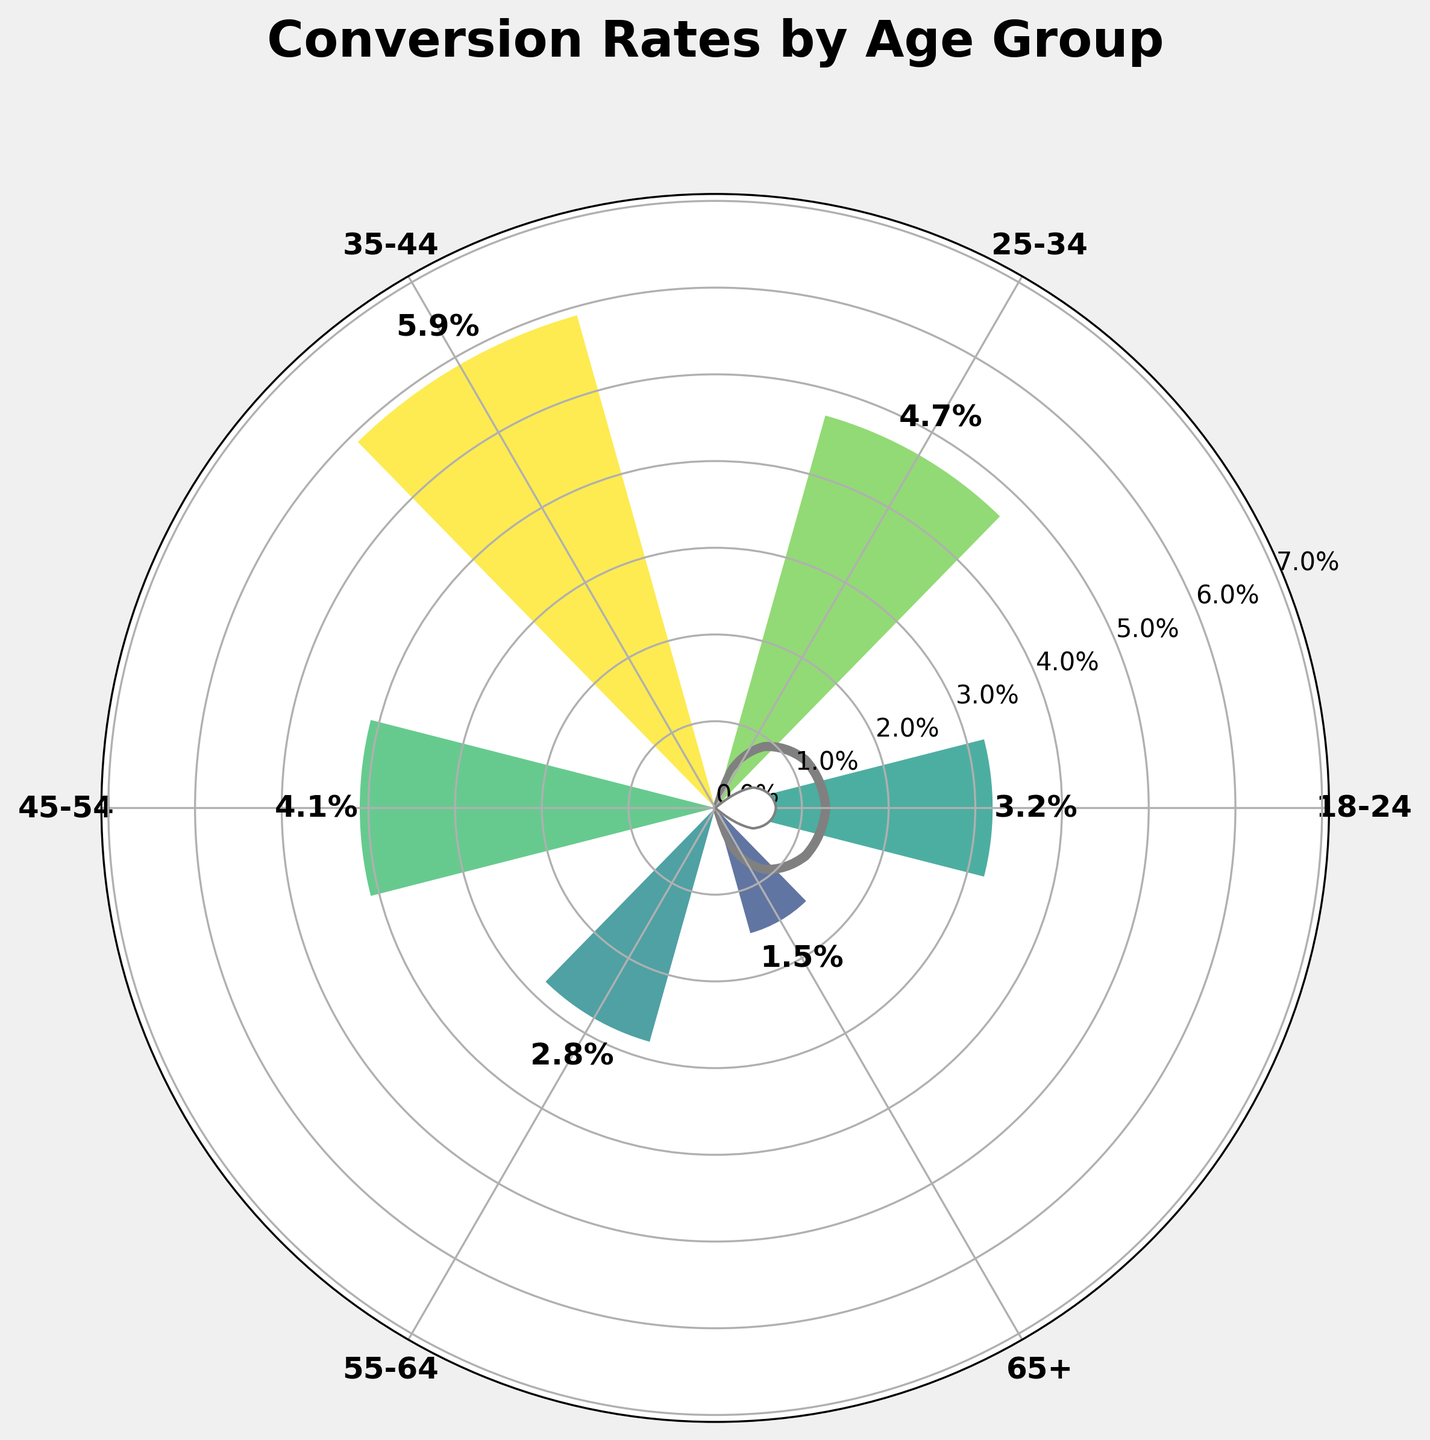What is the conversion rate for the 18-24 age group? To get this information, simply look at the section of the gauge chart labeled "18-24" and check the conversion rate value next to it. The figure shows the conversion rate for each age group on the gauge itself.
Answer: 3.2% What is the highest conversion rate among all age groups? Scan through the conversion rates for all age groups to find the maximum value. The highest conversion rate is clearly labeled on the gauge chart.
Answer: 5.9% How many age groups have a conversion rate below 4%? Look at the conversion rates for each age group on the chart and count how many are below 4%. The age groups with conversion rates below 4% are 18-24, 55-64, and 65+.
Answer: 3 Which age group has the lowest conversion rate? Examine the conversion rates for each age group on the chart to determine the one with the smallest value. The lowest value is annotated next to the age group.
Answer: 65+ What is the difference in conversion rates between the 25-34 and 65+ age groups? Identify the conversion rates for both age groups from the chart—25-34 is 4.7% and 65+ is 1.5%. Subtract the 65+ conversion rate from the 25-34 conversion rate to find the difference.
Answer: 3.2% What is the average conversion rate for all age groups? Sum up all the conversion rates: 3.2 + 4.7 + 5.9 + 4.1 + 2.8 + 1.5 = 22.2. Then, divide this sum by the number of age groups (6) to find the average.
Answer: 3.7% Which age group has a higher conversion rate: 18-24 or 45-54? Compare the conversion rates listed for the 18-24 and 45-54 age groups. The chart shows that 45-54 has 4.1% while 18-24 has 3.2%.
Answer: 45-54 What are the conversion rates for age groups directly adjacent to the 35-44 age group on the chart? The 35-44 age group has 25-34 on one side and 45-54 on the other. Retrieve the conversion rates for these groups from the chart.
Answer: 4.7% and 4.1% How does the conversion rate for the 55-64 age group compare to the overall average conversion rate? First, find the average conversion rate (3.7%). Then, compare this average to the conversion rate for the 55-64 age group (2.8%).
Answer: Below average What's the total conversion rate for all age groups combined? Sum all the conversion rates directly from the chart data: 3.2 + 4.7 + 5.9 + 4.1 + 2.8 + 1.5 = 22.2.
Answer: 22.2% 